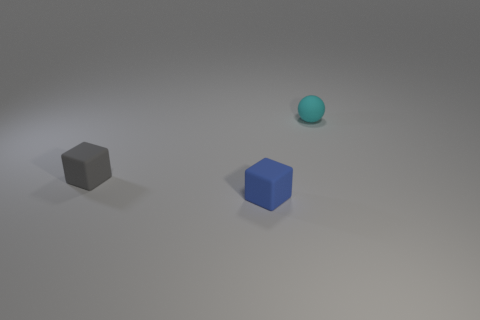Add 2 tiny gray cubes. How many objects exist? 5 Subtract all blocks. How many objects are left? 1 Add 1 blue things. How many blue things exist? 2 Subtract 0 yellow blocks. How many objects are left? 3 Subtract all small cyan things. Subtract all cyan things. How many objects are left? 1 Add 3 tiny blocks. How many tiny blocks are left? 5 